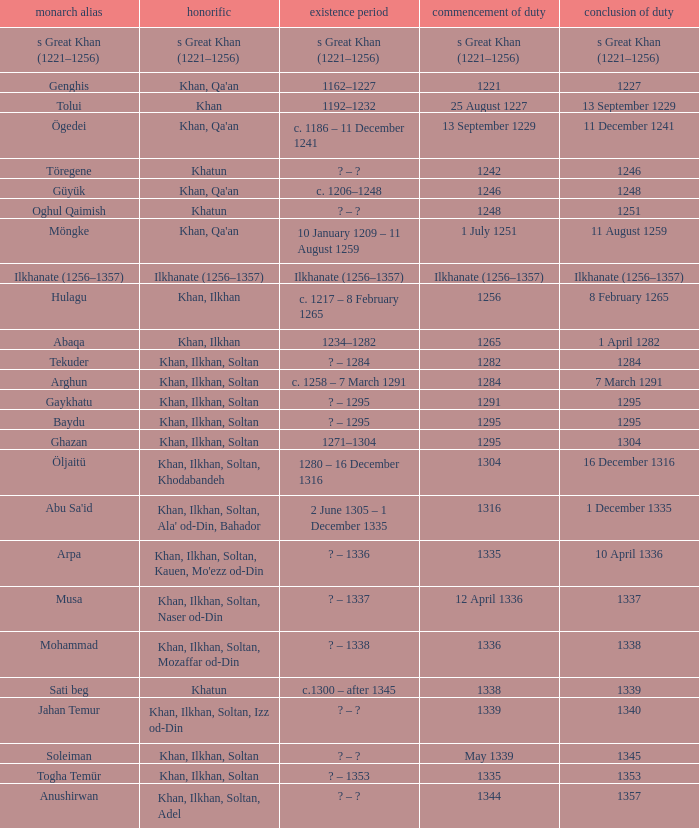What is the born-died that has office of 13 September 1229 as the entered? C. 1186 – 11 december 1241. 